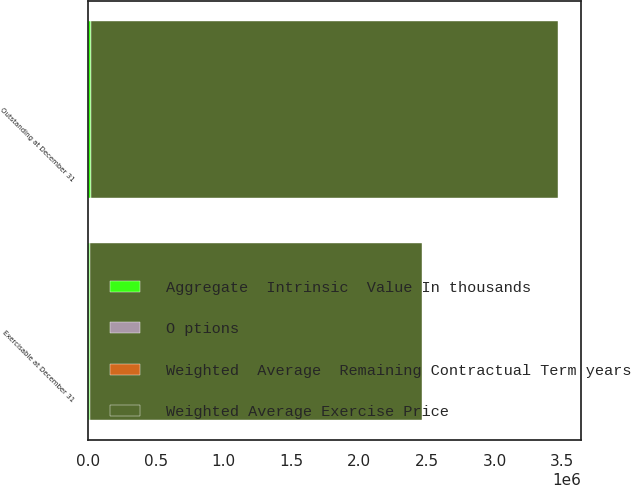Convert chart. <chart><loc_0><loc_0><loc_500><loc_500><stacked_bar_chart><ecel><fcel>Outstanding at December 31<fcel>Exercisable at December 31<nl><fcel>Weighted Average Exercise Price<fcel>3.45108e+06<fcel>2.45114e+06<nl><fcel>Weighted  Average  Remaining Contractual Term years<fcel>17.96<fcel>16.51<nl><fcel>O ptions<fcel>5.5<fcel>5.1<nl><fcel>Aggregate  Intrinsic  Value In thousands<fcel>15420<fcel>14281<nl></chart> 